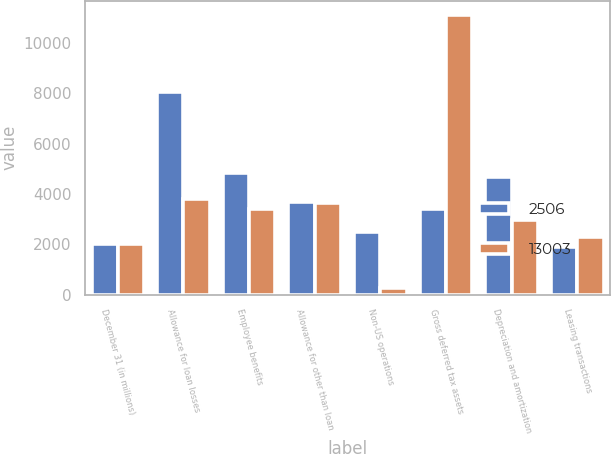Convert chart to OTSL. <chart><loc_0><loc_0><loc_500><loc_500><stacked_bar_chart><ecel><fcel>December 31 (in millions)<fcel>Allowance for loan losses<fcel>Employee benefits<fcel>Allowance for other than loan<fcel>Non-US operations<fcel>Gross deferred tax assets<fcel>Depreciation and amortization<fcel>Leasing transactions<nl><fcel>2506<fcel>2008<fcel>8029<fcel>4841<fcel>3686<fcel>2504<fcel>3391<fcel>4681<fcel>1895<nl><fcel>13003<fcel>2007<fcel>3800<fcel>3391<fcel>3635<fcel>285<fcel>11111<fcel>2966<fcel>2304<nl></chart> 